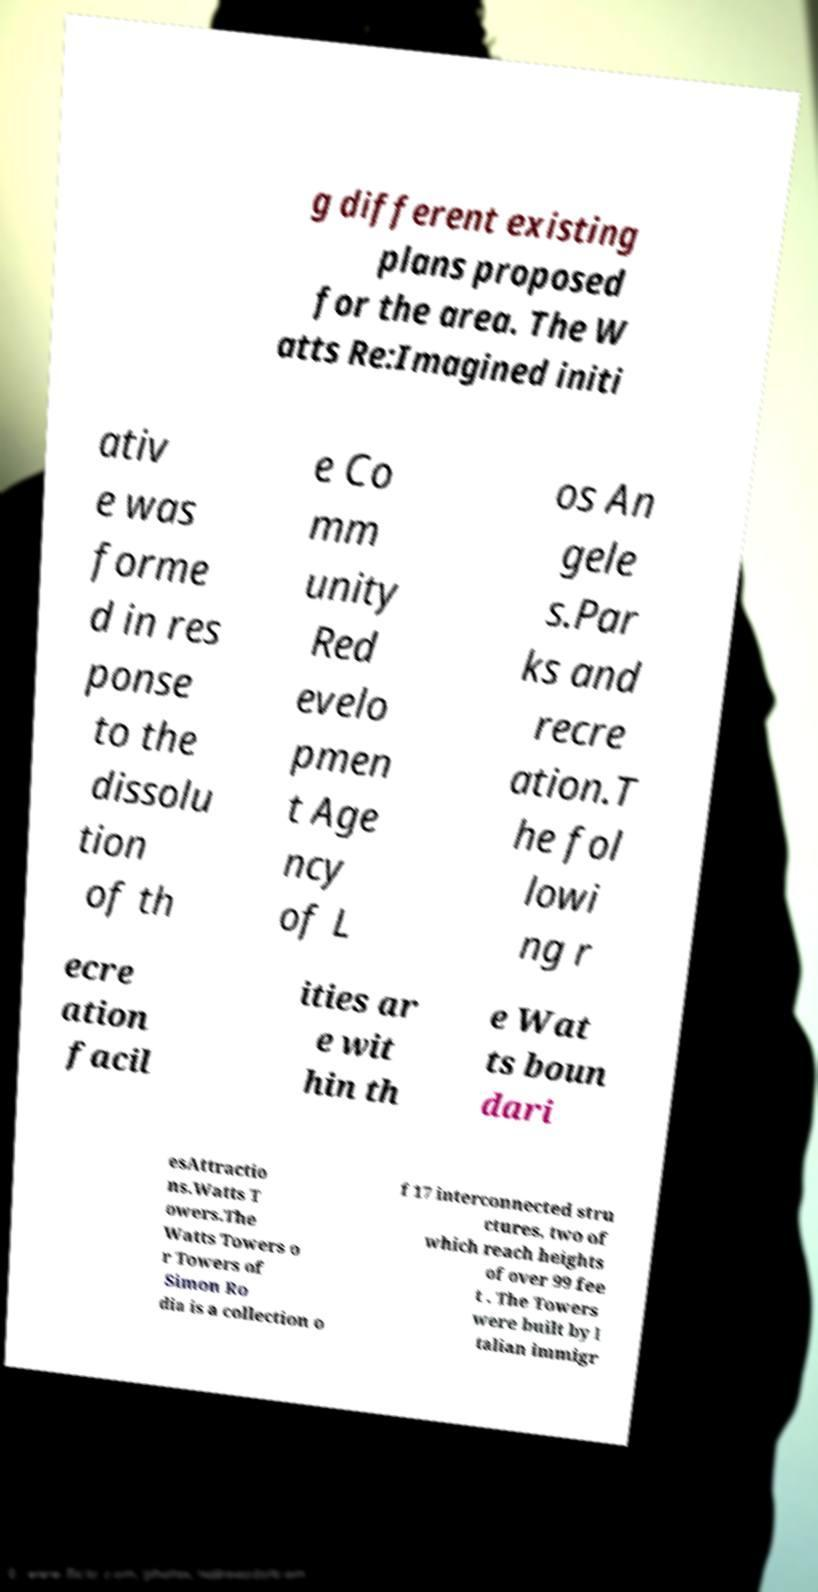Could you assist in decoding the text presented in this image and type it out clearly? g different existing plans proposed for the area. The W atts Re:Imagined initi ativ e was forme d in res ponse to the dissolu tion of th e Co mm unity Red evelo pmen t Age ncy of L os An gele s.Par ks and recre ation.T he fol lowi ng r ecre ation facil ities ar e wit hin th e Wat ts boun dari esAttractio ns.Watts T owers.The Watts Towers o r Towers of Simon Ro dia is a collection o f 17 interconnected stru ctures, two of which reach heights of over 99 fee t . The Towers were built by I talian immigr 